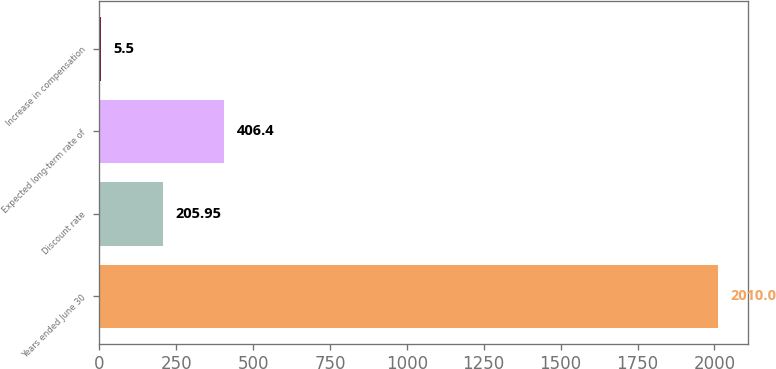Convert chart to OTSL. <chart><loc_0><loc_0><loc_500><loc_500><bar_chart><fcel>Years ended June 30<fcel>Discount rate<fcel>Expected long-term rate of<fcel>Increase in compensation<nl><fcel>2010<fcel>205.95<fcel>406.4<fcel>5.5<nl></chart> 